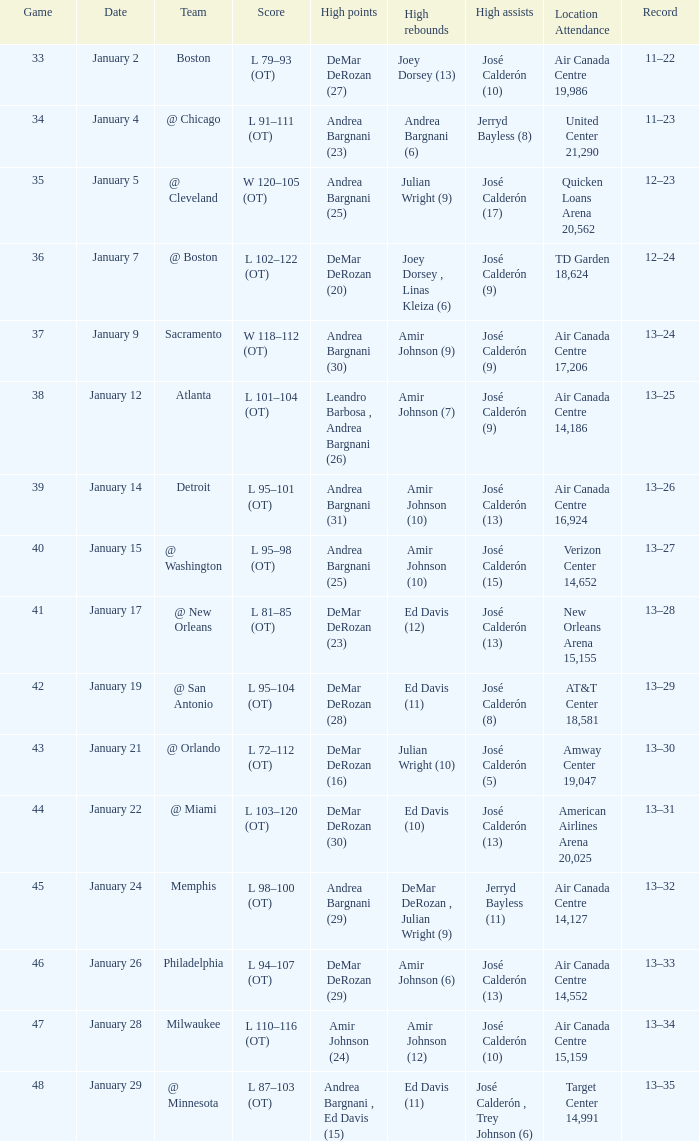On january 5, what was the quantity of high rebounds? 1.0. 